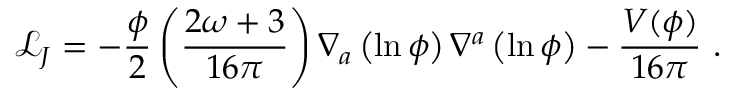Convert formula to latex. <formula><loc_0><loc_0><loc_500><loc_500>\mathcal { L } _ { J } = - \frac { \phi } { 2 } \left ( \frac { 2 \omega + 3 } { 1 6 \pi } \right ) \nabla _ { a } \left ( \ln { \phi } \right ) \nabla ^ { a } \left ( \ln { \phi } \right ) - \frac { V ( \phi ) } { 1 6 \pi } .</formula> 